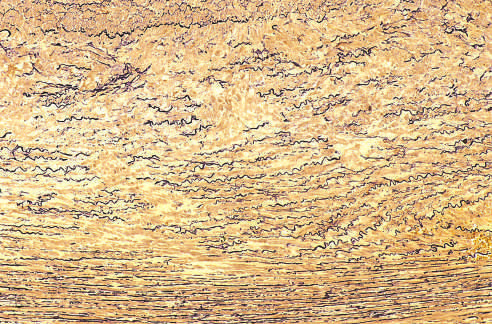did wilms tumor with tightly packed blue cells consistent with the blastemal component and show marked elastin fragmentation and areas devoid of elastin that resemble cystic spaces asterisks?
Answer the question using a single word or phrase. No 